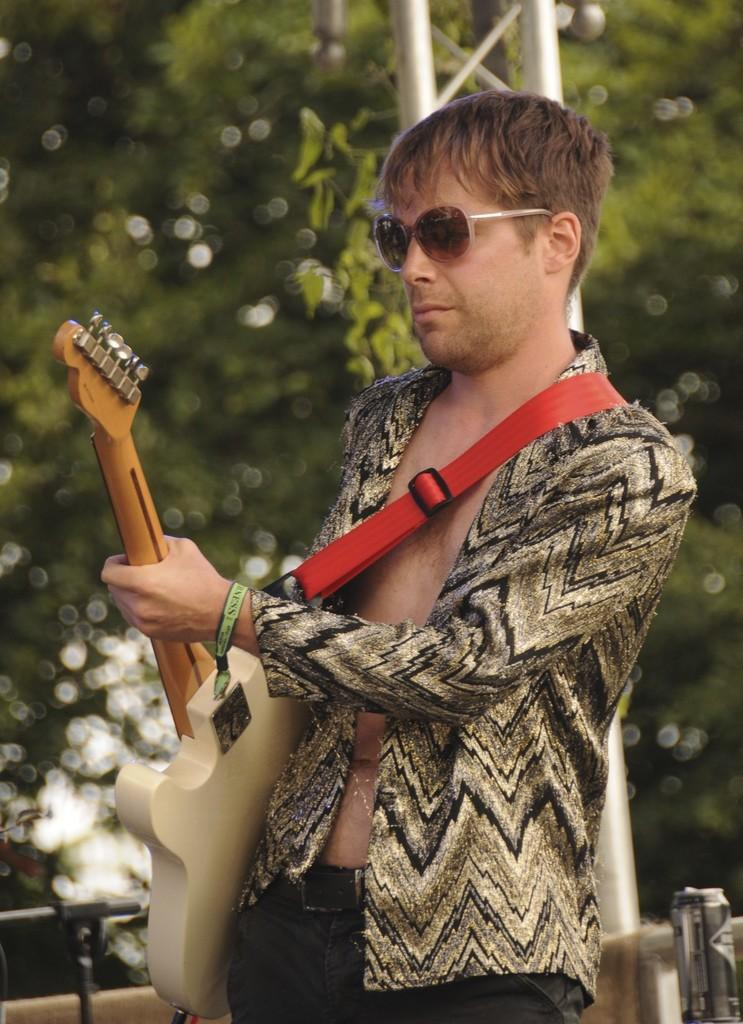What is the person in the image wearing? The person is wearing a blazer and black pants. What is the person doing in the image? The person is standing and holding a guitar. What can be seen in the background of the image? There is a metal pole and trees in the background of the image. What type of corn is growing on the person's head in the image? There is no corn present in the image, and the person's head is not shown. 